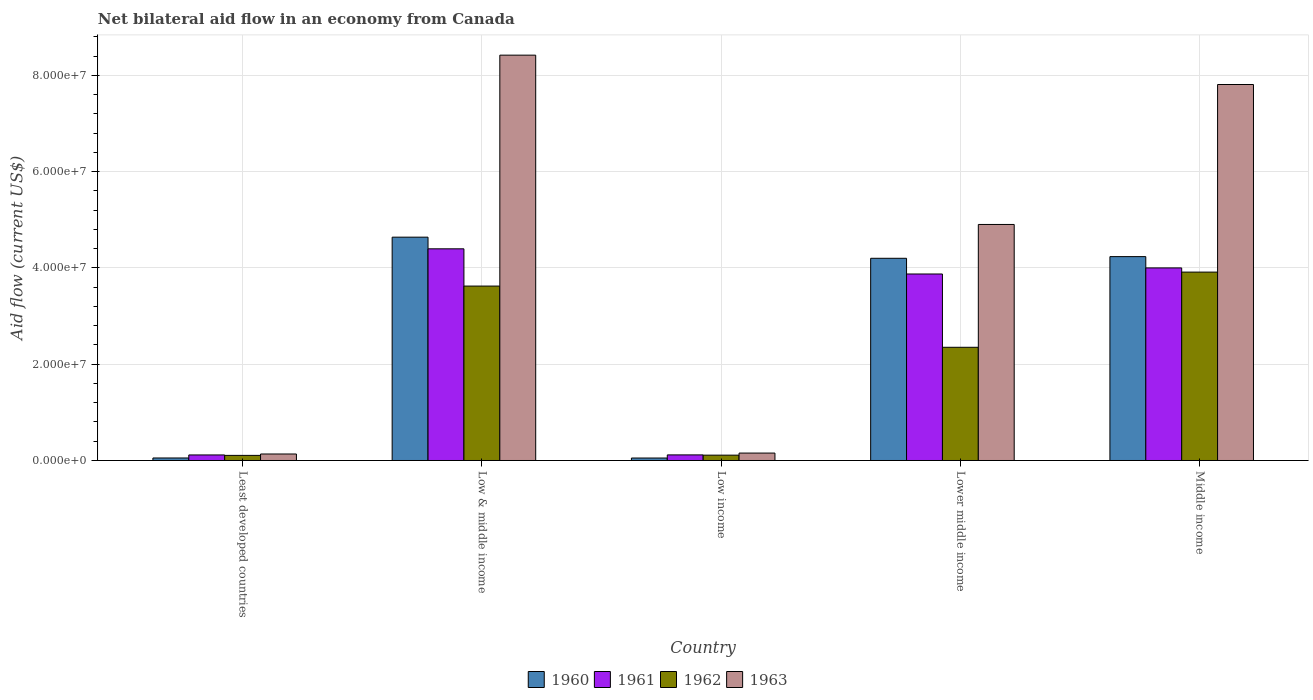How many different coloured bars are there?
Your answer should be compact. 4. How many groups of bars are there?
Give a very brief answer. 5. How many bars are there on the 3rd tick from the left?
Make the answer very short. 4. What is the net bilateral aid flow in 1960 in Low & middle income?
Ensure brevity in your answer.  4.64e+07. Across all countries, what is the maximum net bilateral aid flow in 1963?
Make the answer very short. 8.42e+07. Across all countries, what is the minimum net bilateral aid flow in 1962?
Make the answer very short. 1.06e+06. In which country was the net bilateral aid flow in 1961 maximum?
Offer a terse response. Low & middle income. In which country was the net bilateral aid flow in 1960 minimum?
Offer a terse response. Low income. What is the total net bilateral aid flow in 1962 in the graph?
Offer a very short reply. 1.01e+08. What is the difference between the net bilateral aid flow in 1961 in Low & middle income and that in Lower middle income?
Your answer should be very brief. 5.23e+06. What is the difference between the net bilateral aid flow in 1960 in Middle income and the net bilateral aid flow in 1962 in Low income?
Make the answer very short. 4.12e+07. What is the average net bilateral aid flow in 1963 per country?
Make the answer very short. 4.29e+07. What is the ratio of the net bilateral aid flow in 1963 in Least developed countries to that in Lower middle income?
Ensure brevity in your answer.  0.03. Is the net bilateral aid flow in 1963 in Low income less than that in Lower middle income?
Offer a very short reply. Yes. Is the difference between the net bilateral aid flow in 1962 in Low & middle income and Lower middle income greater than the difference between the net bilateral aid flow in 1961 in Low & middle income and Lower middle income?
Your answer should be compact. Yes. What is the difference between the highest and the second highest net bilateral aid flow in 1960?
Provide a short and direct response. 4.39e+06. What is the difference between the highest and the lowest net bilateral aid flow in 1961?
Your answer should be compact. 4.28e+07. Is the sum of the net bilateral aid flow in 1961 in Low income and Middle income greater than the maximum net bilateral aid flow in 1963 across all countries?
Offer a very short reply. No. How many bars are there?
Make the answer very short. 20. Are all the bars in the graph horizontal?
Your answer should be very brief. No. How many countries are there in the graph?
Offer a very short reply. 5. What is the difference between two consecutive major ticks on the Y-axis?
Make the answer very short. 2.00e+07. Are the values on the major ticks of Y-axis written in scientific E-notation?
Give a very brief answer. Yes. How many legend labels are there?
Ensure brevity in your answer.  4. What is the title of the graph?
Keep it short and to the point. Net bilateral aid flow in an economy from Canada. Does "1990" appear as one of the legend labels in the graph?
Your response must be concise. No. What is the label or title of the X-axis?
Your answer should be very brief. Country. What is the Aid flow (current US$) of 1960 in Least developed countries?
Give a very brief answer. 5.20e+05. What is the Aid flow (current US$) of 1961 in Least developed countries?
Give a very brief answer. 1.15e+06. What is the Aid flow (current US$) in 1962 in Least developed countries?
Provide a succinct answer. 1.06e+06. What is the Aid flow (current US$) in 1963 in Least developed countries?
Keep it short and to the point. 1.35e+06. What is the Aid flow (current US$) of 1960 in Low & middle income?
Offer a very short reply. 4.64e+07. What is the Aid flow (current US$) of 1961 in Low & middle income?
Offer a very short reply. 4.40e+07. What is the Aid flow (current US$) of 1962 in Low & middle income?
Give a very brief answer. 3.62e+07. What is the Aid flow (current US$) of 1963 in Low & middle income?
Your response must be concise. 8.42e+07. What is the Aid flow (current US$) of 1960 in Low income?
Ensure brevity in your answer.  5.10e+05. What is the Aid flow (current US$) of 1961 in Low income?
Provide a succinct answer. 1.16e+06. What is the Aid flow (current US$) of 1962 in Low income?
Your answer should be very brief. 1.11e+06. What is the Aid flow (current US$) in 1963 in Low income?
Your answer should be very brief. 1.54e+06. What is the Aid flow (current US$) of 1960 in Lower middle income?
Offer a terse response. 4.20e+07. What is the Aid flow (current US$) in 1961 in Lower middle income?
Make the answer very short. 3.88e+07. What is the Aid flow (current US$) of 1962 in Lower middle income?
Your answer should be very brief. 2.35e+07. What is the Aid flow (current US$) of 1963 in Lower middle income?
Make the answer very short. 4.90e+07. What is the Aid flow (current US$) of 1960 in Middle income?
Make the answer very short. 4.24e+07. What is the Aid flow (current US$) of 1961 in Middle income?
Your answer should be compact. 4.00e+07. What is the Aid flow (current US$) in 1962 in Middle income?
Ensure brevity in your answer.  3.91e+07. What is the Aid flow (current US$) of 1963 in Middle income?
Offer a very short reply. 7.81e+07. Across all countries, what is the maximum Aid flow (current US$) of 1960?
Provide a short and direct response. 4.64e+07. Across all countries, what is the maximum Aid flow (current US$) of 1961?
Make the answer very short. 4.40e+07. Across all countries, what is the maximum Aid flow (current US$) in 1962?
Offer a terse response. 3.91e+07. Across all countries, what is the maximum Aid flow (current US$) of 1963?
Provide a succinct answer. 8.42e+07. Across all countries, what is the minimum Aid flow (current US$) in 1960?
Ensure brevity in your answer.  5.10e+05. Across all countries, what is the minimum Aid flow (current US$) in 1961?
Your response must be concise. 1.15e+06. Across all countries, what is the minimum Aid flow (current US$) in 1962?
Your response must be concise. 1.06e+06. Across all countries, what is the minimum Aid flow (current US$) of 1963?
Give a very brief answer. 1.35e+06. What is the total Aid flow (current US$) in 1960 in the graph?
Provide a succinct answer. 1.32e+08. What is the total Aid flow (current US$) of 1961 in the graph?
Your answer should be very brief. 1.25e+08. What is the total Aid flow (current US$) of 1962 in the graph?
Provide a short and direct response. 1.01e+08. What is the total Aid flow (current US$) of 1963 in the graph?
Ensure brevity in your answer.  2.14e+08. What is the difference between the Aid flow (current US$) in 1960 in Least developed countries and that in Low & middle income?
Your answer should be very brief. -4.59e+07. What is the difference between the Aid flow (current US$) in 1961 in Least developed countries and that in Low & middle income?
Give a very brief answer. -4.28e+07. What is the difference between the Aid flow (current US$) in 1962 in Least developed countries and that in Low & middle income?
Your response must be concise. -3.52e+07. What is the difference between the Aid flow (current US$) in 1963 in Least developed countries and that in Low & middle income?
Your answer should be compact. -8.29e+07. What is the difference between the Aid flow (current US$) of 1961 in Least developed countries and that in Low income?
Keep it short and to the point. -10000. What is the difference between the Aid flow (current US$) of 1960 in Least developed countries and that in Lower middle income?
Your answer should be compact. -4.15e+07. What is the difference between the Aid flow (current US$) in 1961 in Least developed countries and that in Lower middle income?
Your answer should be very brief. -3.76e+07. What is the difference between the Aid flow (current US$) of 1962 in Least developed countries and that in Lower middle income?
Offer a terse response. -2.25e+07. What is the difference between the Aid flow (current US$) in 1963 in Least developed countries and that in Lower middle income?
Give a very brief answer. -4.77e+07. What is the difference between the Aid flow (current US$) in 1960 in Least developed countries and that in Middle income?
Offer a terse response. -4.18e+07. What is the difference between the Aid flow (current US$) of 1961 in Least developed countries and that in Middle income?
Provide a short and direct response. -3.89e+07. What is the difference between the Aid flow (current US$) in 1962 in Least developed countries and that in Middle income?
Offer a very short reply. -3.81e+07. What is the difference between the Aid flow (current US$) of 1963 in Least developed countries and that in Middle income?
Keep it short and to the point. -7.68e+07. What is the difference between the Aid flow (current US$) in 1960 in Low & middle income and that in Low income?
Keep it short and to the point. 4.59e+07. What is the difference between the Aid flow (current US$) in 1961 in Low & middle income and that in Low income?
Provide a succinct answer. 4.28e+07. What is the difference between the Aid flow (current US$) in 1962 in Low & middle income and that in Low income?
Your answer should be very brief. 3.51e+07. What is the difference between the Aid flow (current US$) of 1963 in Low & middle income and that in Low income?
Give a very brief answer. 8.27e+07. What is the difference between the Aid flow (current US$) in 1960 in Low & middle income and that in Lower middle income?
Provide a short and direct response. 4.39e+06. What is the difference between the Aid flow (current US$) in 1961 in Low & middle income and that in Lower middle income?
Offer a very short reply. 5.23e+06. What is the difference between the Aid flow (current US$) of 1962 in Low & middle income and that in Lower middle income?
Give a very brief answer. 1.27e+07. What is the difference between the Aid flow (current US$) of 1963 in Low & middle income and that in Lower middle income?
Give a very brief answer. 3.52e+07. What is the difference between the Aid flow (current US$) in 1960 in Low & middle income and that in Middle income?
Keep it short and to the point. 4.04e+06. What is the difference between the Aid flow (current US$) of 1961 in Low & middle income and that in Middle income?
Offer a terse response. 3.97e+06. What is the difference between the Aid flow (current US$) of 1962 in Low & middle income and that in Middle income?
Your answer should be compact. -2.90e+06. What is the difference between the Aid flow (current US$) in 1963 in Low & middle income and that in Middle income?
Offer a very short reply. 6.10e+06. What is the difference between the Aid flow (current US$) of 1960 in Low income and that in Lower middle income?
Your answer should be compact. -4.15e+07. What is the difference between the Aid flow (current US$) of 1961 in Low income and that in Lower middle income?
Offer a terse response. -3.76e+07. What is the difference between the Aid flow (current US$) of 1962 in Low income and that in Lower middle income?
Your response must be concise. -2.24e+07. What is the difference between the Aid flow (current US$) of 1963 in Low income and that in Lower middle income?
Ensure brevity in your answer.  -4.75e+07. What is the difference between the Aid flow (current US$) in 1960 in Low income and that in Middle income?
Keep it short and to the point. -4.18e+07. What is the difference between the Aid flow (current US$) in 1961 in Low income and that in Middle income?
Ensure brevity in your answer.  -3.88e+07. What is the difference between the Aid flow (current US$) in 1962 in Low income and that in Middle income?
Offer a terse response. -3.80e+07. What is the difference between the Aid flow (current US$) in 1963 in Low income and that in Middle income?
Your answer should be compact. -7.66e+07. What is the difference between the Aid flow (current US$) in 1960 in Lower middle income and that in Middle income?
Offer a very short reply. -3.50e+05. What is the difference between the Aid flow (current US$) in 1961 in Lower middle income and that in Middle income?
Ensure brevity in your answer.  -1.26e+06. What is the difference between the Aid flow (current US$) of 1962 in Lower middle income and that in Middle income?
Provide a short and direct response. -1.56e+07. What is the difference between the Aid flow (current US$) of 1963 in Lower middle income and that in Middle income?
Give a very brief answer. -2.91e+07. What is the difference between the Aid flow (current US$) in 1960 in Least developed countries and the Aid flow (current US$) in 1961 in Low & middle income?
Your answer should be very brief. -4.35e+07. What is the difference between the Aid flow (current US$) in 1960 in Least developed countries and the Aid flow (current US$) in 1962 in Low & middle income?
Give a very brief answer. -3.57e+07. What is the difference between the Aid flow (current US$) in 1960 in Least developed countries and the Aid flow (current US$) in 1963 in Low & middle income?
Keep it short and to the point. -8.37e+07. What is the difference between the Aid flow (current US$) of 1961 in Least developed countries and the Aid flow (current US$) of 1962 in Low & middle income?
Ensure brevity in your answer.  -3.51e+07. What is the difference between the Aid flow (current US$) of 1961 in Least developed countries and the Aid flow (current US$) of 1963 in Low & middle income?
Give a very brief answer. -8.31e+07. What is the difference between the Aid flow (current US$) in 1962 in Least developed countries and the Aid flow (current US$) in 1963 in Low & middle income?
Make the answer very short. -8.32e+07. What is the difference between the Aid flow (current US$) of 1960 in Least developed countries and the Aid flow (current US$) of 1961 in Low income?
Give a very brief answer. -6.40e+05. What is the difference between the Aid flow (current US$) in 1960 in Least developed countries and the Aid flow (current US$) in 1962 in Low income?
Give a very brief answer. -5.90e+05. What is the difference between the Aid flow (current US$) of 1960 in Least developed countries and the Aid flow (current US$) of 1963 in Low income?
Provide a short and direct response. -1.02e+06. What is the difference between the Aid flow (current US$) of 1961 in Least developed countries and the Aid flow (current US$) of 1962 in Low income?
Offer a terse response. 4.00e+04. What is the difference between the Aid flow (current US$) of 1961 in Least developed countries and the Aid flow (current US$) of 1963 in Low income?
Keep it short and to the point. -3.90e+05. What is the difference between the Aid flow (current US$) in 1962 in Least developed countries and the Aid flow (current US$) in 1963 in Low income?
Your answer should be compact. -4.80e+05. What is the difference between the Aid flow (current US$) in 1960 in Least developed countries and the Aid flow (current US$) in 1961 in Lower middle income?
Provide a succinct answer. -3.82e+07. What is the difference between the Aid flow (current US$) in 1960 in Least developed countries and the Aid flow (current US$) in 1962 in Lower middle income?
Keep it short and to the point. -2.30e+07. What is the difference between the Aid flow (current US$) of 1960 in Least developed countries and the Aid flow (current US$) of 1963 in Lower middle income?
Your answer should be very brief. -4.85e+07. What is the difference between the Aid flow (current US$) in 1961 in Least developed countries and the Aid flow (current US$) in 1962 in Lower middle income?
Make the answer very short. -2.24e+07. What is the difference between the Aid flow (current US$) of 1961 in Least developed countries and the Aid flow (current US$) of 1963 in Lower middle income?
Provide a short and direct response. -4.79e+07. What is the difference between the Aid flow (current US$) of 1962 in Least developed countries and the Aid flow (current US$) of 1963 in Lower middle income?
Give a very brief answer. -4.80e+07. What is the difference between the Aid flow (current US$) in 1960 in Least developed countries and the Aid flow (current US$) in 1961 in Middle income?
Offer a very short reply. -3.95e+07. What is the difference between the Aid flow (current US$) in 1960 in Least developed countries and the Aid flow (current US$) in 1962 in Middle income?
Your answer should be compact. -3.86e+07. What is the difference between the Aid flow (current US$) of 1960 in Least developed countries and the Aid flow (current US$) of 1963 in Middle income?
Your answer should be very brief. -7.76e+07. What is the difference between the Aid flow (current US$) in 1961 in Least developed countries and the Aid flow (current US$) in 1962 in Middle income?
Give a very brief answer. -3.80e+07. What is the difference between the Aid flow (current US$) of 1961 in Least developed countries and the Aid flow (current US$) of 1963 in Middle income?
Your response must be concise. -7.70e+07. What is the difference between the Aid flow (current US$) of 1962 in Least developed countries and the Aid flow (current US$) of 1963 in Middle income?
Keep it short and to the point. -7.71e+07. What is the difference between the Aid flow (current US$) of 1960 in Low & middle income and the Aid flow (current US$) of 1961 in Low income?
Offer a terse response. 4.52e+07. What is the difference between the Aid flow (current US$) in 1960 in Low & middle income and the Aid flow (current US$) in 1962 in Low income?
Provide a succinct answer. 4.53e+07. What is the difference between the Aid flow (current US$) of 1960 in Low & middle income and the Aid flow (current US$) of 1963 in Low income?
Your response must be concise. 4.49e+07. What is the difference between the Aid flow (current US$) of 1961 in Low & middle income and the Aid flow (current US$) of 1962 in Low income?
Offer a very short reply. 4.29e+07. What is the difference between the Aid flow (current US$) in 1961 in Low & middle income and the Aid flow (current US$) in 1963 in Low income?
Offer a very short reply. 4.24e+07. What is the difference between the Aid flow (current US$) in 1962 in Low & middle income and the Aid flow (current US$) in 1963 in Low income?
Offer a terse response. 3.47e+07. What is the difference between the Aid flow (current US$) of 1960 in Low & middle income and the Aid flow (current US$) of 1961 in Lower middle income?
Provide a succinct answer. 7.65e+06. What is the difference between the Aid flow (current US$) in 1960 in Low & middle income and the Aid flow (current US$) in 1962 in Lower middle income?
Your answer should be compact. 2.29e+07. What is the difference between the Aid flow (current US$) of 1960 in Low & middle income and the Aid flow (current US$) of 1963 in Lower middle income?
Your answer should be compact. -2.64e+06. What is the difference between the Aid flow (current US$) in 1961 in Low & middle income and the Aid flow (current US$) in 1962 in Lower middle income?
Provide a succinct answer. 2.05e+07. What is the difference between the Aid flow (current US$) of 1961 in Low & middle income and the Aid flow (current US$) of 1963 in Lower middle income?
Give a very brief answer. -5.06e+06. What is the difference between the Aid flow (current US$) in 1962 in Low & middle income and the Aid flow (current US$) in 1963 in Lower middle income?
Your answer should be compact. -1.28e+07. What is the difference between the Aid flow (current US$) of 1960 in Low & middle income and the Aid flow (current US$) of 1961 in Middle income?
Give a very brief answer. 6.39e+06. What is the difference between the Aid flow (current US$) of 1960 in Low & middle income and the Aid flow (current US$) of 1962 in Middle income?
Give a very brief answer. 7.26e+06. What is the difference between the Aid flow (current US$) of 1960 in Low & middle income and the Aid flow (current US$) of 1963 in Middle income?
Offer a terse response. -3.17e+07. What is the difference between the Aid flow (current US$) of 1961 in Low & middle income and the Aid flow (current US$) of 1962 in Middle income?
Provide a succinct answer. 4.84e+06. What is the difference between the Aid flow (current US$) in 1961 in Low & middle income and the Aid flow (current US$) in 1963 in Middle income?
Give a very brief answer. -3.41e+07. What is the difference between the Aid flow (current US$) in 1962 in Low & middle income and the Aid flow (current US$) in 1963 in Middle income?
Keep it short and to the point. -4.19e+07. What is the difference between the Aid flow (current US$) of 1960 in Low income and the Aid flow (current US$) of 1961 in Lower middle income?
Keep it short and to the point. -3.82e+07. What is the difference between the Aid flow (current US$) of 1960 in Low income and the Aid flow (current US$) of 1962 in Lower middle income?
Your answer should be compact. -2.30e+07. What is the difference between the Aid flow (current US$) in 1960 in Low income and the Aid flow (current US$) in 1963 in Lower middle income?
Your response must be concise. -4.85e+07. What is the difference between the Aid flow (current US$) of 1961 in Low income and the Aid flow (current US$) of 1962 in Lower middle income?
Your answer should be very brief. -2.24e+07. What is the difference between the Aid flow (current US$) of 1961 in Low income and the Aid flow (current US$) of 1963 in Lower middle income?
Offer a terse response. -4.79e+07. What is the difference between the Aid flow (current US$) of 1962 in Low income and the Aid flow (current US$) of 1963 in Lower middle income?
Keep it short and to the point. -4.79e+07. What is the difference between the Aid flow (current US$) in 1960 in Low income and the Aid flow (current US$) in 1961 in Middle income?
Provide a succinct answer. -3.95e+07. What is the difference between the Aid flow (current US$) in 1960 in Low income and the Aid flow (current US$) in 1962 in Middle income?
Provide a succinct answer. -3.86e+07. What is the difference between the Aid flow (current US$) of 1960 in Low income and the Aid flow (current US$) of 1963 in Middle income?
Your response must be concise. -7.76e+07. What is the difference between the Aid flow (current US$) of 1961 in Low income and the Aid flow (current US$) of 1962 in Middle income?
Your response must be concise. -3.80e+07. What is the difference between the Aid flow (current US$) of 1961 in Low income and the Aid flow (current US$) of 1963 in Middle income?
Offer a very short reply. -7.70e+07. What is the difference between the Aid flow (current US$) in 1962 in Low income and the Aid flow (current US$) in 1963 in Middle income?
Keep it short and to the point. -7.70e+07. What is the difference between the Aid flow (current US$) of 1960 in Lower middle income and the Aid flow (current US$) of 1962 in Middle income?
Provide a succinct answer. 2.87e+06. What is the difference between the Aid flow (current US$) of 1960 in Lower middle income and the Aid flow (current US$) of 1963 in Middle income?
Offer a very short reply. -3.61e+07. What is the difference between the Aid flow (current US$) in 1961 in Lower middle income and the Aid flow (current US$) in 1962 in Middle income?
Make the answer very short. -3.90e+05. What is the difference between the Aid flow (current US$) of 1961 in Lower middle income and the Aid flow (current US$) of 1963 in Middle income?
Your response must be concise. -3.94e+07. What is the difference between the Aid flow (current US$) in 1962 in Lower middle income and the Aid flow (current US$) in 1963 in Middle income?
Your answer should be compact. -5.46e+07. What is the average Aid flow (current US$) in 1960 per country?
Your response must be concise. 2.64e+07. What is the average Aid flow (current US$) of 1961 per country?
Provide a succinct answer. 2.50e+07. What is the average Aid flow (current US$) of 1962 per country?
Your answer should be compact. 2.02e+07. What is the average Aid flow (current US$) in 1963 per country?
Make the answer very short. 4.29e+07. What is the difference between the Aid flow (current US$) in 1960 and Aid flow (current US$) in 1961 in Least developed countries?
Your response must be concise. -6.30e+05. What is the difference between the Aid flow (current US$) in 1960 and Aid flow (current US$) in 1962 in Least developed countries?
Ensure brevity in your answer.  -5.40e+05. What is the difference between the Aid flow (current US$) of 1960 and Aid flow (current US$) of 1963 in Least developed countries?
Your answer should be very brief. -8.30e+05. What is the difference between the Aid flow (current US$) in 1961 and Aid flow (current US$) in 1962 in Least developed countries?
Make the answer very short. 9.00e+04. What is the difference between the Aid flow (current US$) of 1961 and Aid flow (current US$) of 1963 in Least developed countries?
Your answer should be very brief. -2.00e+05. What is the difference between the Aid flow (current US$) of 1962 and Aid flow (current US$) of 1963 in Least developed countries?
Make the answer very short. -2.90e+05. What is the difference between the Aid flow (current US$) in 1960 and Aid flow (current US$) in 1961 in Low & middle income?
Provide a short and direct response. 2.42e+06. What is the difference between the Aid flow (current US$) in 1960 and Aid flow (current US$) in 1962 in Low & middle income?
Provide a succinct answer. 1.02e+07. What is the difference between the Aid flow (current US$) of 1960 and Aid flow (current US$) of 1963 in Low & middle income?
Provide a short and direct response. -3.78e+07. What is the difference between the Aid flow (current US$) of 1961 and Aid flow (current US$) of 1962 in Low & middle income?
Give a very brief answer. 7.74e+06. What is the difference between the Aid flow (current US$) of 1961 and Aid flow (current US$) of 1963 in Low & middle income?
Give a very brief answer. -4.02e+07. What is the difference between the Aid flow (current US$) in 1962 and Aid flow (current US$) in 1963 in Low & middle income?
Ensure brevity in your answer.  -4.80e+07. What is the difference between the Aid flow (current US$) of 1960 and Aid flow (current US$) of 1961 in Low income?
Provide a short and direct response. -6.50e+05. What is the difference between the Aid flow (current US$) in 1960 and Aid flow (current US$) in 1962 in Low income?
Your answer should be compact. -6.00e+05. What is the difference between the Aid flow (current US$) in 1960 and Aid flow (current US$) in 1963 in Low income?
Your response must be concise. -1.03e+06. What is the difference between the Aid flow (current US$) of 1961 and Aid flow (current US$) of 1963 in Low income?
Ensure brevity in your answer.  -3.80e+05. What is the difference between the Aid flow (current US$) in 1962 and Aid flow (current US$) in 1963 in Low income?
Ensure brevity in your answer.  -4.30e+05. What is the difference between the Aid flow (current US$) of 1960 and Aid flow (current US$) of 1961 in Lower middle income?
Your answer should be compact. 3.26e+06. What is the difference between the Aid flow (current US$) in 1960 and Aid flow (current US$) in 1962 in Lower middle income?
Give a very brief answer. 1.85e+07. What is the difference between the Aid flow (current US$) in 1960 and Aid flow (current US$) in 1963 in Lower middle income?
Offer a terse response. -7.03e+06. What is the difference between the Aid flow (current US$) of 1961 and Aid flow (current US$) of 1962 in Lower middle income?
Keep it short and to the point. 1.52e+07. What is the difference between the Aid flow (current US$) in 1961 and Aid flow (current US$) in 1963 in Lower middle income?
Provide a succinct answer. -1.03e+07. What is the difference between the Aid flow (current US$) of 1962 and Aid flow (current US$) of 1963 in Lower middle income?
Your response must be concise. -2.55e+07. What is the difference between the Aid flow (current US$) of 1960 and Aid flow (current US$) of 1961 in Middle income?
Your response must be concise. 2.35e+06. What is the difference between the Aid flow (current US$) of 1960 and Aid flow (current US$) of 1962 in Middle income?
Ensure brevity in your answer.  3.22e+06. What is the difference between the Aid flow (current US$) in 1960 and Aid flow (current US$) in 1963 in Middle income?
Offer a terse response. -3.58e+07. What is the difference between the Aid flow (current US$) of 1961 and Aid flow (current US$) of 1962 in Middle income?
Provide a short and direct response. 8.70e+05. What is the difference between the Aid flow (current US$) in 1961 and Aid flow (current US$) in 1963 in Middle income?
Make the answer very short. -3.81e+07. What is the difference between the Aid flow (current US$) of 1962 and Aid flow (current US$) of 1963 in Middle income?
Your answer should be compact. -3.90e+07. What is the ratio of the Aid flow (current US$) in 1960 in Least developed countries to that in Low & middle income?
Offer a very short reply. 0.01. What is the ratio of the Aid flow (current US$) of 1961 in Least developed countries to that in Low & middle income?
Give a very brief answer. 0.03. What is the ratio of the Aid flow (current US$) of 1962 in Least developed countries to that in Low & middle income?
Ensure brevity in your answer.  0.03. What is the ratio of the Aid flow (current US$) of 1963 in Least developed countries to that in Low & middle income?
Provide a succinct answer. 0.02. What is the ratio of the Aid flow (current US$) of 1960 in Least developed countries to that in Low income?
Provide a short and direct response. 1.02. What is the ratio of the Aid flow (current US$) of 1962 in Least developed countries to that in Low income?
Your answer should be very brief. 0.95. What is the ratio of the Aid flow (current US$) of 1963 in Least developed countries to that in Low income?
Make the answer very short. 0.88. What is the ratio of the Aid flow (current US$) of 1960 in Least developed countries to that in Lower middle income?
Your answer should be very brief. 0.01. What is the ratio of the Aid flow (current US$) in 1961 in Least developed countries to that in Lower middle income?
Offer a very short reply. 0.03. What is the ratio of the Aid flow (current US$) of 1962 in Least developed countries to that in Lower middle income?
Make the answer very short. 0.05. What is the ratio of the Aid flow (current US$) of 1963 in Least developed countries to that in Lower middle income?
Offer a very short reply. 0.03. What is the ratio of the Aid flow (current US$) in 1960 in Least developed countries to that in Middle income?
Your answer should be compact. 0.01. What is the ratio of the Aid flow (current US$) in 1961 in Least developed countries to that in Middle income?
Offer a terse response. 0.03. What is the ratio of the Aid flow (current US$) of 1962 in Least developed countries to that in Middle income?
Provide a short and direct response. 0.03. What is the ratio of the Aid flow (current US$) of 1963 in Least developed countries to that in Middle income?
Provide a short and direct response. 0.02. What is the ratio of the Aid flow (current US$) in 1960 in Low & middle income to that in Low income?
Provide a succinct answer. 90.98. What is the ratio of the Aid flow (current US$) in 1961 in Low & middle income to that in Low income?
Make the answer very short. 37.91. What is the ratio of the Aid flow (current US$) in 1962 in Low & middle income to that in Low income?
Offer a terse response. 32.65. What is the ratio of the Aid flow (current US$) of 1963 in Low & middle income to that in Low income?
Make the answer very short. 54.69. What is the ratio of the Aid flow (current US$) in 1960 in Low & middle income to that in Lower middle income?
Give a very brief answer. 1.1. What is the ratio of the Aid flow (current US$) of 1961 in Low & middle income to that in Lower middle income?
Your answer should be very brief. 1.14. What is the ratio of the Aid flow (current US$) of 1962 in Low & middle income to that in Lower middle income?
Your answer should be compact. 1.54. What is the ratio of the Aid flow (current US$) of 1963 in Low & middle income to that in Lower middle income?
Offer a terse response. 1.72. What is the ratio of the Aid flow (current US$) in 1960 in Low & middle income to that in Middle income?
Give a very brief answer. 1.1. What is the ratio of the Aid flow (current US$) of 1961 in Low & middle income to that in Middle income?
Provide a short and direct response. 1.1. What is the ratio of the Aid flow (current US$) of 1962 in Low & middle income to that in Middle income?
Give a very brief answer. 0.93. What is the ratio of the Aid flow (current US$) in 1963 in Low & middle income to that in Middle income?
Your response must be concise. 1.08. What is the ratio of the Aid flow (current US$) in 1960 in Low income to that in Lower middle income?
Offer a terse response. 0.01. What is the ratio of the Aid flow (current US$) in 1961 in Low income to that in Lower middle income?
Your answer should be very brief. 0.03. What is the ratio of the Aid flow (current US$) of 1962 in Low income to that in Lower middle income?
Your response must be concise. 0.05. What is the ratio of the Aid flow (current US$) of 1963 in Low income to that in Lower middle income?
Your response must be concise. 0.03. What is the ratio of the Aid flow (current US$) of 1960 in Low income to that in Middle income?
Your answer should be compact. 0.01. What is the ratio of the Aid flow (current US$) in 1961 in Low income to that in Middle income?
Provide a succinct answer. 0.03. What is the ratio of the Aid flow (current US$) of 1962 in Low income to that in Middle income?
Your answer should be very brief. 0.03. What is the ratio of the Aid flow (current US$) of 1963 in Low income to that in Middle income?
Your response must be concise. 0.02. What is the ratio of the Aid flow (current US$) in 1960 in Lower middle income to that in Middle income?
Make the answer very short. 0.99. What is the ratio of the Aid flow (current US$) in 1961 in Lower middle income to that in Middle income?
Offer a very short reply. 0.97. What is the ratio of the Aid flow (current US$) of 1962 in Lower middle income to that in Middle income?
Offer a very short reply. 0.6. What is the ratio of the Aid flow (current US$) in 1963 in Lower middle income to that in Middle income?
Provide a succinct answer. 0.63. What is the difference between the highest and the second highest Aid flow (current US$) in 1960?
Your answer should be compact. 4.04e+06. What is the difference between the highest and the second highest Aid flow (current US$) of 1961?
Your answer should be very brief. 3.97e+06. What is the difference between the highest and the second highest Aid flow (current US$) of 1962?
Make the answer very short. 2.90e+06. What is the difference between the highest and the second highest Aid flow (current US$) of 1963?
Offer a very short reply. 6.10e+06. What is the difference between the highest and the lowest Aid flow (current US$) of 1960?
Give a very brief answer. 4.59e+07. What is the difference between the highest and the lowest Aid flow (current US$) of 1961?
Ensure brevity in your answer.  4.28e+07. What is the difference between the highest and the lowest Aid flow (current US$) in 1962?
Make the answer very short. 3.81e+07. What is the difference between the highest and the lowest Aid flow (current US$) in 1963?
Keep it short and to the point. 8.29e+07. 